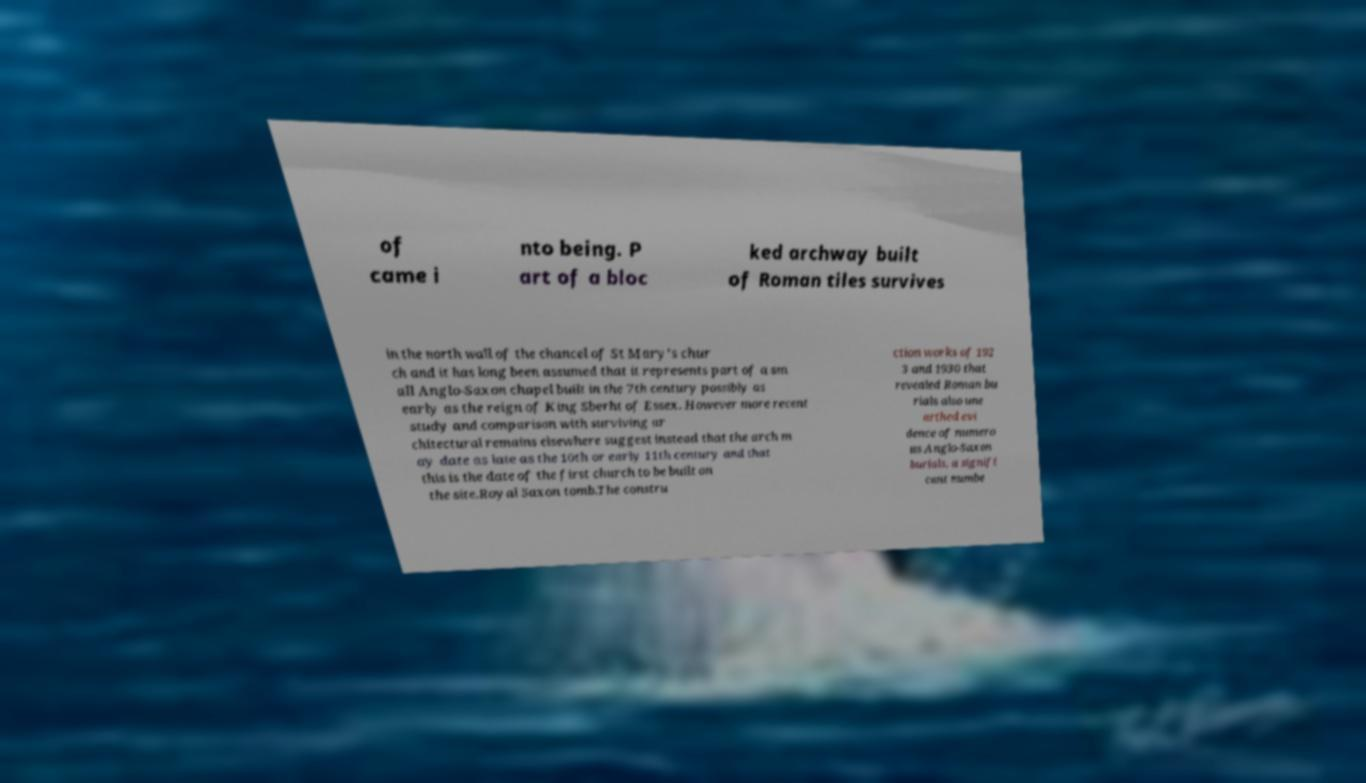Could you extract and type out the text from this image? of came i nto being. P art of a bloc ked archway built of Roman tiles survives in the north wall of the chancel of St Mary's chur ch and it has long been assumed that it represents part of a sm all Anglo-Saxon chapel built in the 7th century possibly as early as the reign of King Sberht of Essex. However more recent study and comparison with surviving ar chitectural remains elsewhere suggest instead that the arch m ay date as late as the 10th or early 11th century and that this is the date of the first church to be built on the site.Royal Saxon tomb.The constru ction works of 192 3 and 1930 that revealed Roman bu rials also une arthed evi dence of numero us Anglo-Saxon burials, a signifi cant numbe 